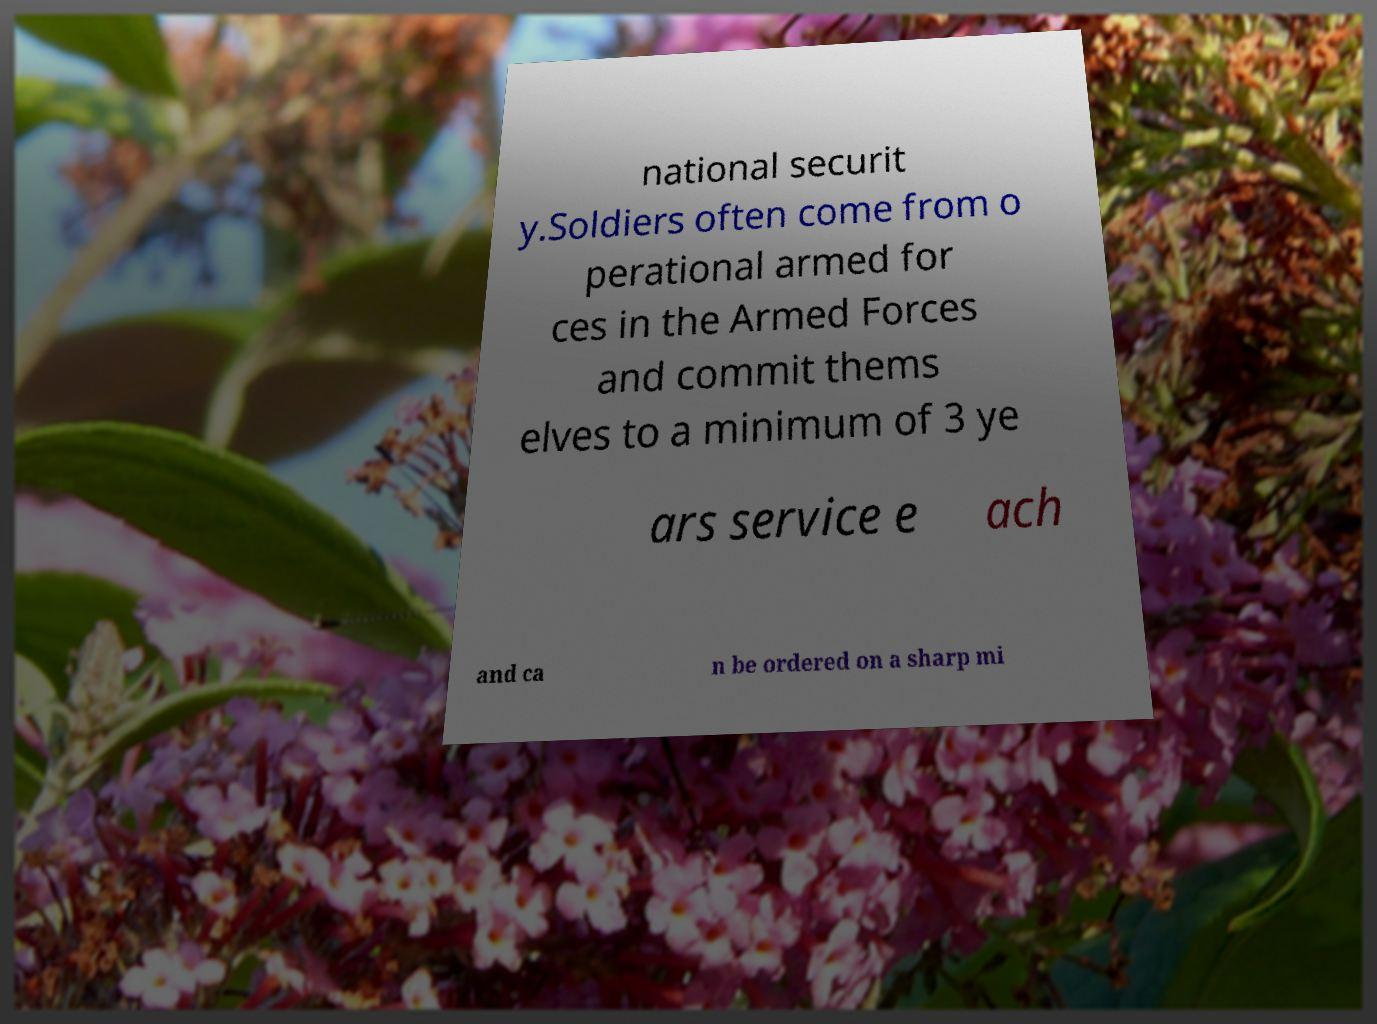Could you assist in decoding the text presented in this image and type it out clearly? national securit y.Soldiers often come from o perational armed for ces in the Armed Forces and commit thems elves to a minimum of 3 ye ars service e ach and ca n be ordered on a sharp mi 